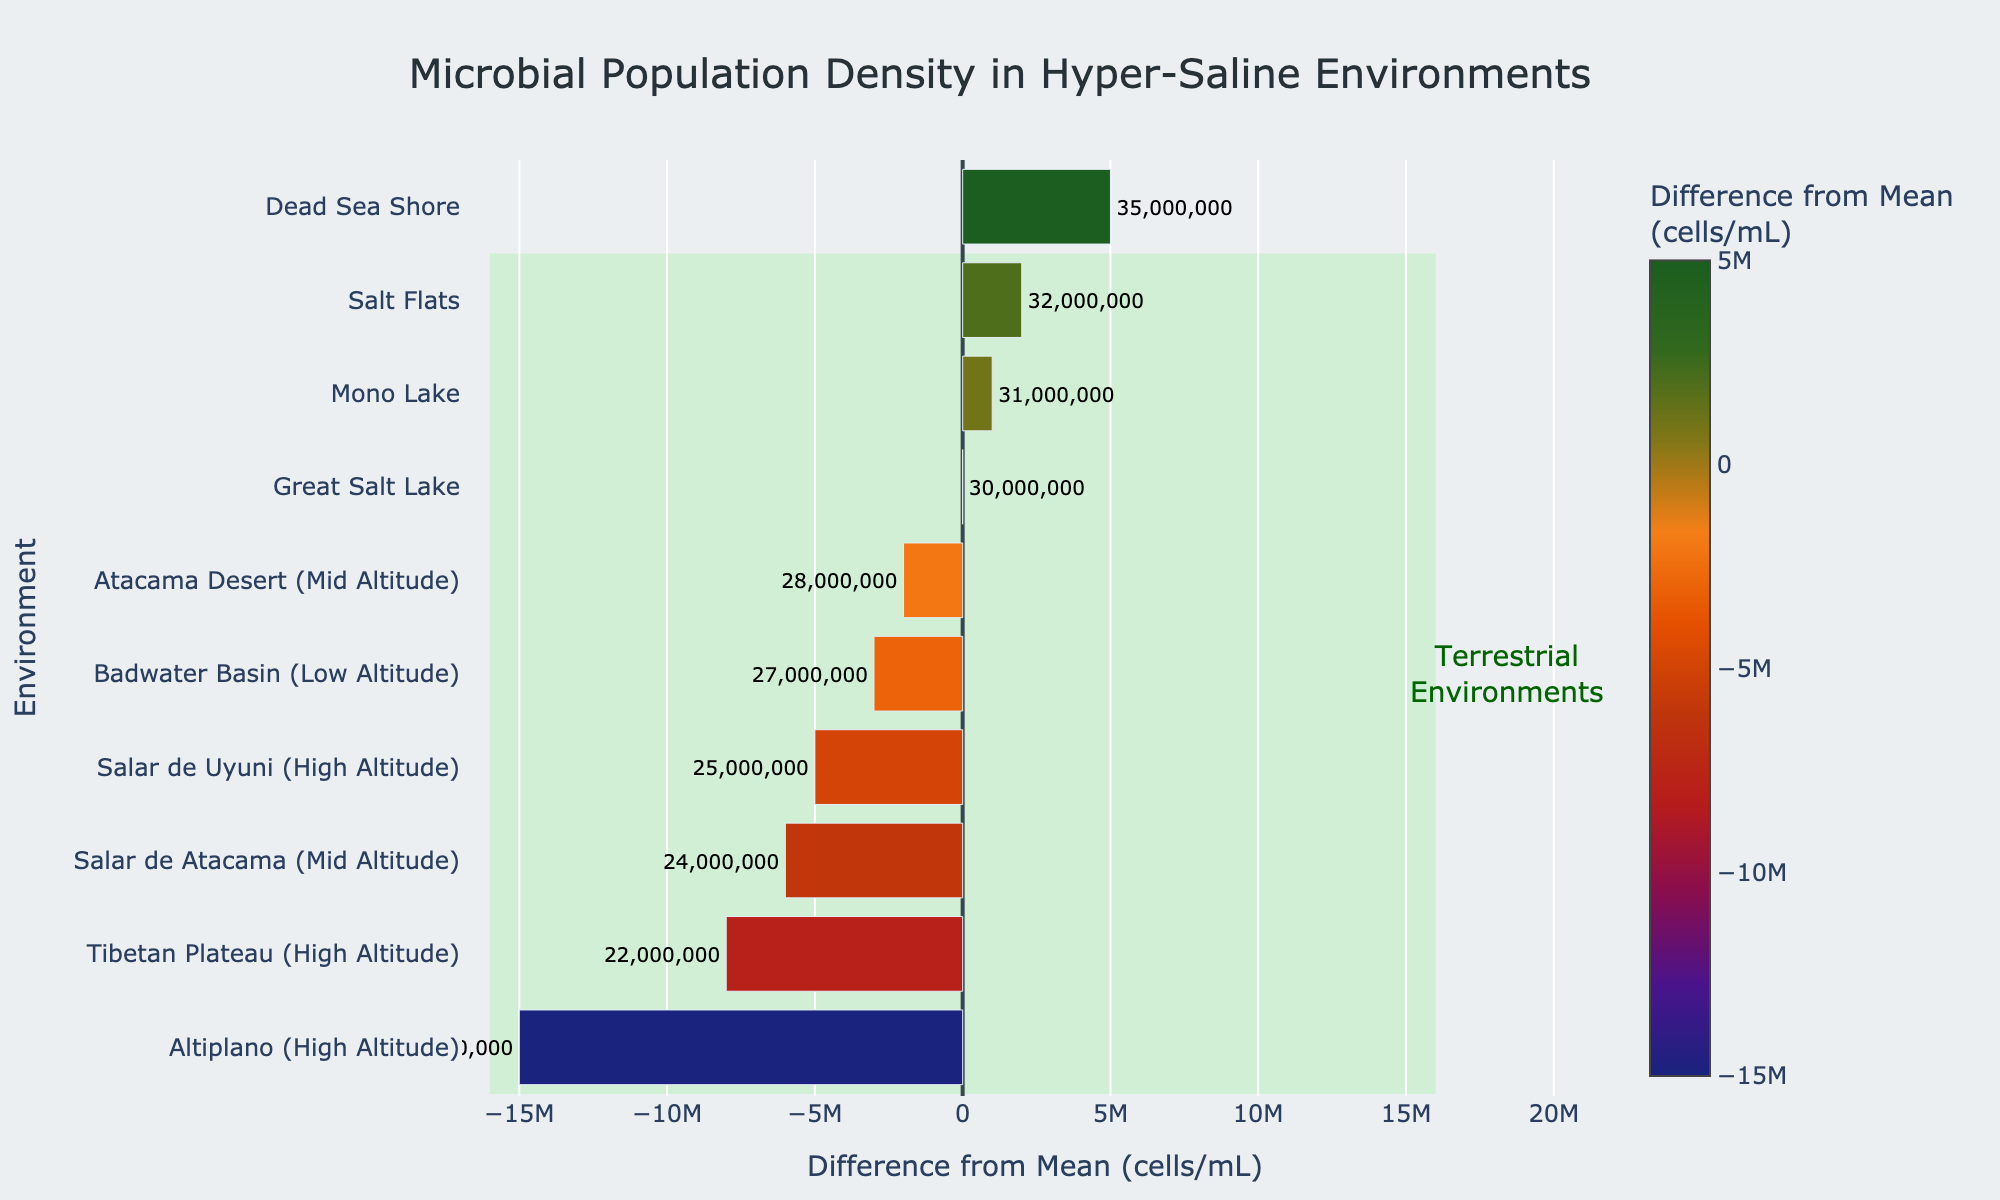What's the environment with the highest microbial population density? Locate the environment with the longest bar extending to the right (positive difference). The Dead Sea Shore has the highest population density.
Answer: Dead Sea Shore Which environment has the lowest population density among terrestrial environments? Compare the lengths of the negative bars for terrestrial environments. The Altiplano (High Altitude) has the largest negative value, indicating the lowest population density among terrestrial environments.
Answer: Altiplano (High Altitude) What is the combined difference from the mean for the Dead Sea Shore and Great Salt Lake? Sum the differences from the mean for Dead Sea Shore (5,000,000) and Great Salt Lake (0). 5,000,000 + 0 = 5,000,000
Answer: 5,000,000 Which environment has a higher population density difference from the mean, Mono Lake or Salt Flats? Compare the bars for Mono Lake and Salt Flats. Salmon Flats has a difference of 2,000,000 and Mono Lake a difference of 1,000,000; thus, Salt Flats has a higher difference.
Answer: Salt Flats What color represents the environment with the largest negative difference from the mean? Identify the color bar extending furthest to the left (negative difference). The Altiplano (High Altitude) has the largest negative difference and is dark blue.
Answer: Dark Blue How many environments have a positive difference from the mean? Count the number of bars extending to the right of the zero line. There are three environments: Dead Sea Shore, Salt Flats, and Mono Lake.
Answer: 3 Which environments fall within the highlighted rectangle for terrestrial environments? List the environments encompassed by the light green rectangle. They are Salt Flats, Altiplano (High Altitude), Atacama Desert (Mid Altitude), Salar de Uyuni (High Altitude), Badwater Basin (Low Altitude), Tibetan Plateau (High Altitude), and Salar de Atacama (Mid Altitude).
Answer: 7 What is the total population density (in cells/mL) combining the Atacama Desert (Mid Altitude) and the Tibetan Plateau (High Altitude)? Add the population densities for Atacama Desert (28,000,000) and Tibetan Plateau (22,000,000). 28,000,000 + 22,000,000 = 50,000,000
Answer: 50,000,000 Which marine environment has the lowest population density? Identify the marine environments and compare their population densities. The Great Salt Lake has the lowest population density among marine environments.
Answer: Great Salt Lake 